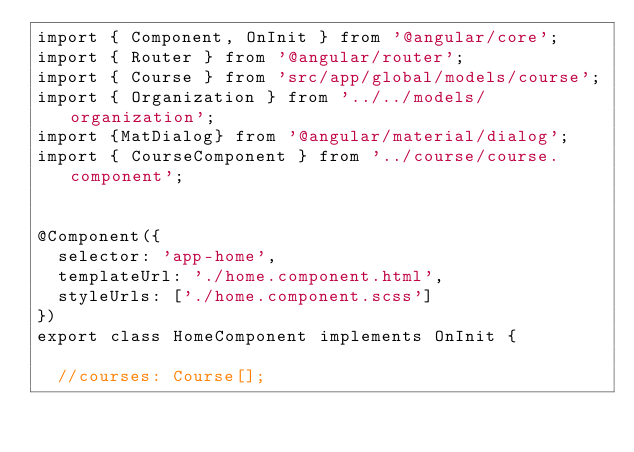Convert code to text. <code><loc_0><loc_0><loc_500><loc_500><_TypeScript_>import { Component, OnInit } from '@angular/core';
import { Router } from '@angular/router';
import { Course } from 'src/app/global/models/course';
import { Organization } from '../../models/organization';
import {MatDialog} from '@angular/material/dialog';
import { CourseComponent } from '../course/course.component';


@Component({
  selector: 'app-home',
  templateUrl: './home.component.html',
  styleUrls: ['./home.component.scss']
})
export class HomeComponent implements OnInit {

  //courses: Course[];</code> 